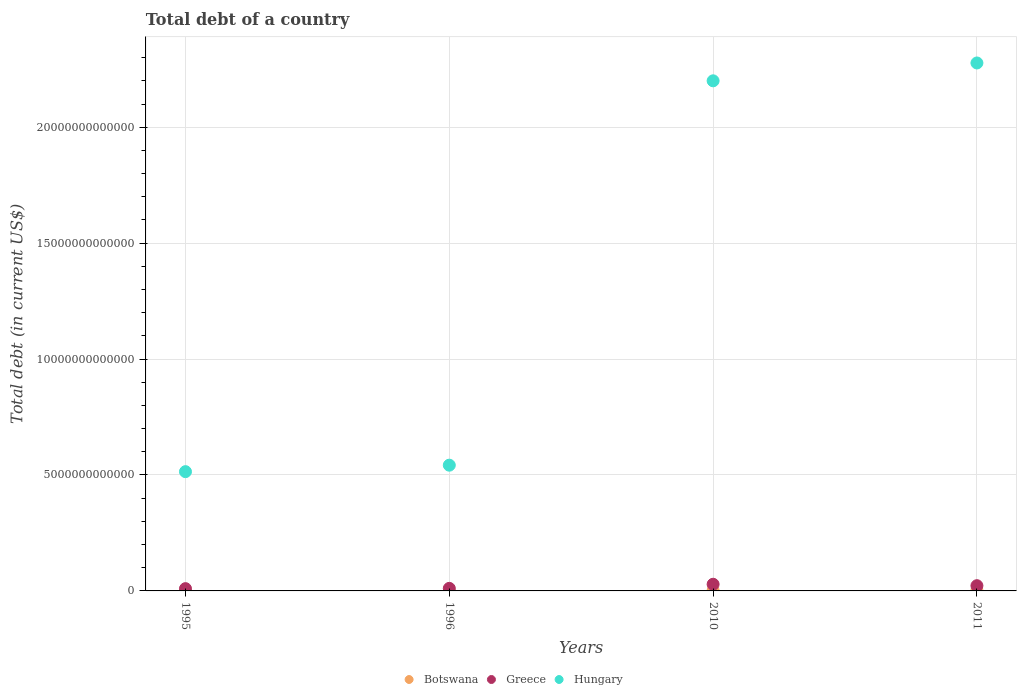What is the debt in Hungary in 2010?
Keep it short and to the point. 2.20e+13. Across all years, what is the maximum debt in Greece?
Make the answer very short. 2.87e+11. Across all years, what is the minimum debt in Botswana?
Make the answer very short. 1.44e+09. What is the total debt in Botswana in the graph?
Your response must be concise. 4.33e+1. What is the difference between the debt in Hungary in 1995 and that in 1996?
Give a very brief answer. -2.79e+11. What is the difference between the debt in Greece in 2011 and the debt in Botswana in 2010?
Provide a succinct answer. 2.07e+11. What is the average debt in Botswana per year?
Provide a succinct answer. 1.08e+1. In the year 1996, what is the difference between the debt in Greece and debt in Hungary?
Offer a terse response. -5.31e+12. In how many years, is the debt in Greece greater than 9000000000000 US$?
Keep it short and to the point. 0. What is the ratio of the debt in Botswana in 1996 to that in 2011?
Give a very brief answer. 0.08. Is the debt in Greece in 2010 less than that in 2011?
Make the answer very short. No. What is the difference between the highest and the second highest debt in Botswana?
Provide a short and direct response. 2.51e+09. What is the difference between the highest and the lowest debt in Botswana?
Provide a short and direct response. 1.99e+1. In how many years, is the debt in Hungary greater than the average debt in Hungary taken over all years?
Give a very brief answer. 2. Is it the case that in every year, the sum of the debt in Botswana and debt in Hungary  is greater than the debt in Greece?
Your answer should be very brief. Yes. Does the debt in Greece monotonically increase over the years?
Make the answer very short. No. Is the debt in Botswana strictly greater than the debt in Hungary over the years?
Offer a very short reply. No. Is the debt in Botswana strictly less than the debt in Greece over the years?
Your answer should be very brief. Yes. How many dotlines are there?
Keep it short and to the point. 3. How many years are there in the graph?
Your answer should be very brief. 4. What is the difference between two consecutive major ticks on the Y-axis?
Your response must be concise. 5.00e+12. Are the values on the major ticks of Y-axis written in scientific E-notation?
Ensure brevity in your answer.  No. Does the graph contain any zero values?
Your answer should be very brief. No. How many legend labels are there?
Ensure brevity in your answer.  3. What is the title of the graph?
Keep it short and to the point. Total debt of a country. Does "Mali" appear as one of the legend labels in the graph?
Provide a succinct answer. No. What is the label or title of the Y-axis?
Your answer should be very brief. Total debt (in current US$). What is the Total debt (in current US$) of Botswana in 1995?
Give a very brief answer. 1.44e+09. What is the Total debt (in current US$) in Greece in 1995?
Provide a succinct answer. 9.79e+1. What is the Total debt (in current US$) of Hungary in 1995?
Your answer should be compact. 5.14e+12. What is the Total debt (in current US$) in Botswana in 1996?
Your response must be concise. 1.80e+09. What is the Total debt (in current US$) in Greece in 1996?
Offer a terse response. 1.10e+11. What is the Total debt (in current US$) in Hungary in 1996?
Ensure brevity in your answer.  5.42e+12. What is the Total debt (in current US$) of Botswana in 2010?
Offer a terse response. 1.88e+1. What is the Total debt (in current US$) of Greece in 2010?
Offer a very short reply. 2.87e+11. What is the Total debt (in current US$) of Hungary in 2010?
Offer a very short reply. 2.20e+13. What is the Total debt (in current US$) in Botswana in 2011?
Offer a terse response. 2.13e+1. What is the Total debt (in current US$) of Greece in 2011?
Ensure brevity in your answer.  2.26e+11. What is the Total debt (in current US$) of Hungary in 2011?
Ensure brevity in your answer.  2.28e+13. Across all years, what is the maximum Total debt (in current US$) of Botswana?
Offer a terse response. 2.13e+1. Across all years, what is the maximum Total debt (in current US$) of Greece?
Keep it short and to the point. 2.87e+11. Across all years, what is the maximum Total debt (in current US$) in Hungary?
Your answer should be very brief. 2.28e+13. Across all years, what is the minimum Total debt (in current US$) in Botswana?
Offer a very short reply. 1.44e+09. Across all years, what is the minimum Total debt (in current US$) in Greece?
Your answer should be very brief. 9.79e+1. Across all years, what is the minimum Total debt (in current US$) in Hungary?
Your response must be concise. 5.14e+12. What is the total Total debt (in current US$) of Botswana in the graph?
Provide a short and direct response. 4.33e+1. What is the total Total debt (in current US$) of Greece in the graph?
Your response must be concise. 7.21e+11. What is the total Total debt (in current US$) of Hungary in the graph?
Keep it short and to the point. 5.53e+13. What is the difference between the Total debt (in current US$) of Botswana in 1995 and that in 1996?
Your answer should be compact. -3.59e+08. What is the difference between the Total debt (in current US$) in Greece in 1995 and that in 1996?
Provide a short and direct response. -1.24e+1. What is the difference between the Total debt (in current US$) in Hungary in 1995 and that in 1996?
Make the answer very short. -2.79e+11. What is the difference between the Total debt (in current US$) in Botswana in 1995 and that in 2010?
Provide a short and direct response. -1.74e+1. What is the difference between the Total debt (in current US$) in Greece in 1995 and that in 2010?
Offer a terse response. -1.89e+11. What is the difference between the Total debt (in current US$) in Hungary in 1995 and that in 2010?
Give a very brief answer. -1.69e+13. What is the difference between the Total debt (in current US$) of Botswana in 1995 and that in 2011?
Your answer should be very brief. -1.99e+1. What is the difference between the Total debt (in current US$) of Greece in 1995 and that in 2011?
Give a very brief answer. -1.28e+11. What is the difference between the Total debt (in current US$) of Hungary in 1995 and that in 2011?
Provide a short and direct response. -1.76e+13. What is the difference between the Total debt (in current US$) of Botswana in 1996 and that in 2010?
Offer a very short reply. -1.70e+1. What is the difference between the Total debt (in current US$) of Greece in 1996 and that in 2010?
Keep it short and to the point. -1.77e+11. What is the difference between the Total debt (in current US$) in Hungary in 1996 and that in 2010?
Your answer should be very brief. -1.66e+13. What is the difference between the Total debt (in current US$) in Botswana in 1996 and that in 2011?
Make the answer very short. -1.95e+1. What is the difference between the Total debt (in current US$) in Greece in 1996 and that in 2011?
Offer a terse response. -1.16e+11. What is the difference between the Total debt (in current US$) in Hungary in 1996 and that in 2011?
Ensure brevity in your answer.  -1.73e+13. What is the difference between the Total debt (in current US$) of Botswana in 2010 and that in 2011?
Give a very brief answer. -2.51e+09. What is the difference between the Total debt (in current US$) of Greece in 2010 and that in 2011?
Offer a very short reply. 6.13e+1. What is the difference between the Total debt (in current US$) in Hungary in 2010 and that in 2011?
Provide a short and direct response. -7.70e+11. What is the difference between the Total debt (in current US$) in Botswana in 1995 and the Total debt (in current US$) in Greece in 1996?
Keep it short and to the point. -1.09e+11. What is the difference between the Total debt (in current US$) in Botswana in 1995 and the Total debt (in current US$) in Hungary in 1996?
Provide a succinct answer. -5.42e+12. What is the difference between the Total debt (in current US$) in Greece in 1995 and the Total debt (in current US$) in Hungary in 1996?
Your answer should be very brief. -5.33e+12. What is the difference between the Total debt (in current US$) of Botswana in 1995 and the Total debt (in current US$) of Greece in 2010?
Ensure brevity in your answer.  -2.86e+11. What is the difference between the Total debt (in current US$) in Botswana in 1995 and the Total debt (in current US$) in Hungary in 2010?
Offer a terse response. -2.20e+13. What is the difference between the Total debt (in current US$) in Greece in 1995 and the Total debt (in current US$) in Hungary in 2010?
Your answer should be compact. -2.19e+13. What is the difference between the Total debt (in current US$) of Botswana in 1995 and the Total debt (in current US$) of Greece in 2011?
Make the answer very short. -2.24e+11. What is the difference between the Total debt (in current US$) in Botswana in 1995 and the Total debt (in current US$) in Hungary in 2011?
Make the answer very short. -2.28e+13. What is the difference between the Total debt (in current US$) in Greece in 1995 and the Total debt (in current US$) in Hungary in 2011?
Your answer should be very brief. -2.27e+13. What is the difference between the Total debt (in current US$) in Botswana in 1996 and the Total debt (in current US$) in Greece in 2010?
Offer a very short reply. -2.85e+11. What is the difference between the Total debt (in current US$) in Botswana in 1996 and the Total debt (in current US$) in Hungary in 2010?
Give a very brief answer. -2.20e+13. What is the difference between the Total debt (in current US$) in Greece in 1996 and the Total debt (in current US$) in Hungary in 2010?
Your answer should be compact. -2.19e+13. What is the difference between the Total debt (in current US$) in Botswana in 1996 and the Total debt (in current US$) in Greece in 2011?
Offer a very short reply. -2.24e+11. What is the difference between the Total debt (in current US$) in Botswana in 1996 and the Total debt (in current US$) in Hungary in 2011?
Your response must be concise. -2.28e+13. What is the difference between the Total debt (in current US$) in Greece in 1996 and the Total debt (in current US$) in Hungary in 2011?
Give a very brief answer. -2.27e+13. What is the difference between the Total debt (in current US$) in Botswana in 2010 and the Total debt (in current US$) in Greece in 2011?
Your answer should be compact. -2.07e+11. What is the difference between the Total debt (in current US$) of Botswana in 2010 and the Total debt (in current US$) of Hungary in 2011?
Keep it short and to the point. -2.28e+13. What is the difference between the Total debt (in current US$) of Greece in 2010 and the Total debt (in current US$) of Hungary in 2011?
Provide a succinct answer. -2.25e+13. What is the average Total debt (in current US$) of Botswana per year?
Your answer should be very brief. 1.08e+1. What is the average Total debt (in current US$) in Greece per year?
Offer a terse response. 1.80e+11. What is the average Total debt (in current US$) of Hungary per year?
Keep it short and to the point. 1.38e+13. In the year 1995, what is the difference between the Total debt (in current US$) of Botswana and Total debt (in current US$) of Greece?
Your response must be concise. -9.65e+1. In the year 1995, what is the difference between the Total debt (in current US$) of Botswana and Total debt (in current US$) of Hungary?
Provide a succinct answer. -5.14e+12. In the year 1995, what is the difference between the Total debt (in current US$) in Greece and Total debt (in current US$) in Hungary?
Your response must be concise. -5.05e+12. In the year 1996, what is the difference between the Total debt (in current US$) in Botswana and Total debt (in current US$) in Greece?
Make the answer very short. -1.08e+11. In the year 1996, what is the difference between the Total debt (in current US$) of Botswana and Total debt (in current US$) of Hungary?
Keep it short and to the point. -5.42e+12. In the year 1996, what is the difference between the Total debt (in current US$) in Greece and Total debt (in current US$) in Hungary?
Keep it short and to the point. -5.31e+12. In the year 2010, what is the difference between the Total debt (in current US$) in Botswana and Total debt (in current US$) in Greece?
Your answer should be very brief. -2.68e+11. In the year 2010, what is the difference between the Total debt (in current US$) of Botswana and Total debt (in current US$) of Hungary?
Make the answer very short. -2.20e+13. In the year 2010, what is the difference between the Total debt (in current US$) in Greece and Total debt (in current US$) in Hungary?
Keep it short and to the point. -2.17e+13. In the year 2011, what is the difference between the Total debt (in current US$) in Botswana and Total debt (in current US$) in Greece?
Give a very brief answer. -2.05e+11. In the year 2011, what is the difference between the Total debt (in current US$) of Botswana and Total debt (in current US$) of Hungary?
Your answer should be very brief. -2.28e+13. In the year 2011, what is the difference between the Total debt (in current US$) in Greece and Total debt (in current US$) in Hungary?
Offer a very short reply. -2.25e+13. What is the ratio of the Total debt (in current US$) of Botswana in 1995 to that in 1996?
Keep it short and to the point. 0.8. What is the ratio of the Total debt (in current US$) in Greece in 1995 to that in 1996?
Offer a terse response. 0.89. What is the ratio of the Total debt (in current US$) of Hungary in 1995 to that in 1996?
Give a very brief answer. 0.95. What is the ratio of the Total debt (in current US$) in Botswana in 1995 to that in 2010?
Make the answer very short. 0.08. What is the ratio of the Total debt (in current US$) in Greece in 1995 to that in 2010?
Your answer should be compact. 0.34. What is the ratio of the Total debt (in current US$) in Hungary in 1995 to that in 2010?
Offer a terse response. 0.23. What is the ratio of the Total debt (in current US$) in Botswana in 1995 to that in 2011?
Your answer should be compact. 0.07. What is the ratio of the Total debt (in current US$) in Greece in 1995 to that in 2011?
Your answer should be compact. 0.43. What is the ratio of the Total debt (in current US$) of Hungary in 1995 to that in 2011?
Offer a very short reply. 0.23. What is the ratio of the Total debt (in current US$) of Botswana in 1996 to that in 2010?
Your answer should be very brief. 0.1. What is the ratio of the Total debt (in current US$) of Greece in 1996 to that in 2010?
Your answer should be compact. 0.38. What is the ratio of the Total debt (in current US$) in Hungary in 1996 to that in 2010?
Ensure brevity in your answer.  0.25. What is the ratio of the Total debt (in current US$) of Botswana in 1996 to that in 2011?
Your answer should be very brief. 0.08. What is the ratio of the Total debt (in current US$) in Greece in 1996 to that in 2011?
Give a very brief answer. 0.49. What is the ratio of the Total debt (in current US$) in Hungary in 1996 to that in 2011?
Your answer should be compact. 0.24. What is the ratio of the Total debt (in current US$) in Botswana in 2010 to that in 2011?
Provide a short and direct response. 0.88. What is the ratio of the Total debt (in current US$) of Greece in 2010 to that in 2011?
Your answer should be very brief. 1.27. What is the ratio of the Total debt (in current US$) in Hungary in 2010 to that in 2011?
Provide a succinct answer. 0.97. What is the difference between the highest and the second highest Total debt (in current US$) in Botswana?
Offer a very short reply. 2.51e+09. What is the difference between the highest and the second highest Total debt (in current US$) of Greece?
Make the answer very short. 6.13e+1. What is the difference between the highest and the second highest Total debt (in current US$) of Hungary?
Provide a succinct answer. 7.70e+11. What is the difference between the highest and the lowest Total debt (in current US$) of Botswana?
Your response must be concise. 1.99e+1. What is the difference between the highest and the lowest Total debt (in current US$) in Greece?
Give a very brief answer. 1.89e+11. What is the difference between the highest and the lowest Total debt (in current US$) in Hungary?
Offer a very short reply. 1.76e+13. 